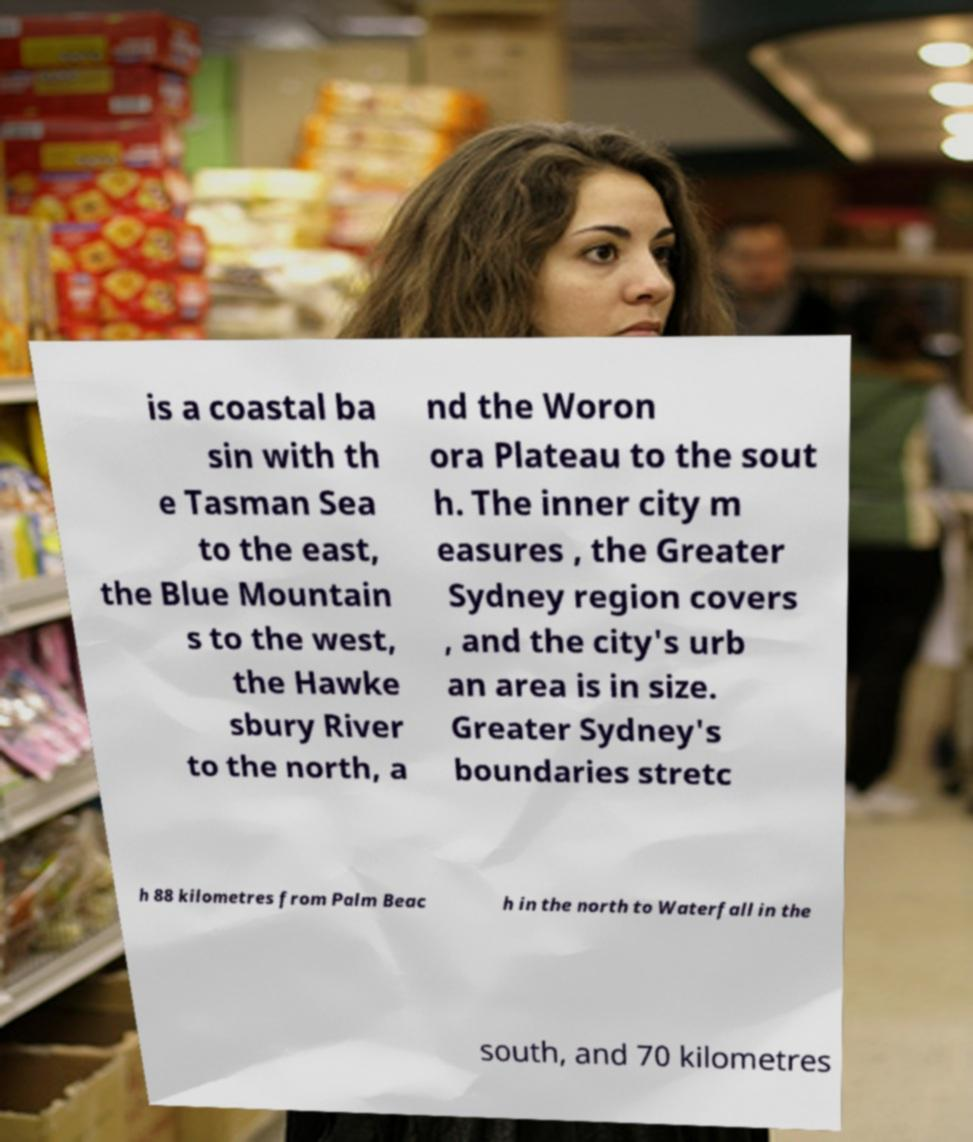For documentation purposes, I need the text within this image transcribed. Could you provide that? is a coastal ba sin with th e Tasman Sea to the east, the Blue Mountain s to the west, the Hawke sbury River to the north, a nd the Woron ora Plateau to the sout h. The inner city m easures , the Greater Sydney region covers , and the city's urb an area is in size. Greater Sydney's boundaries stretc h 88 kilometres from Palm Beac h in the north to Waterfall in the south, and 70 kilometres 